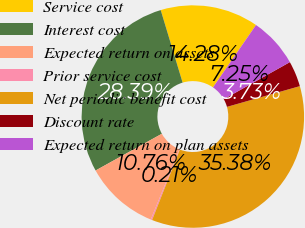Convert chart. <chart><loc_0><loc_0><loc_500><loc_500><pie_chart><fcel>Service cost<fcel>Interest cost<fcel>Expected return on assets<fcel>Prior service cost<fcel>Net periodic benefit cost<fcel>Discount rate<fcel>Expected return on plan assets<nl><fcel>14.28%<fcel>28.39%<fcel>10.76%<fcel>0.21%<fcel>35.38%<fcel>3.73%<fcel>7.25%<nl></chart> 